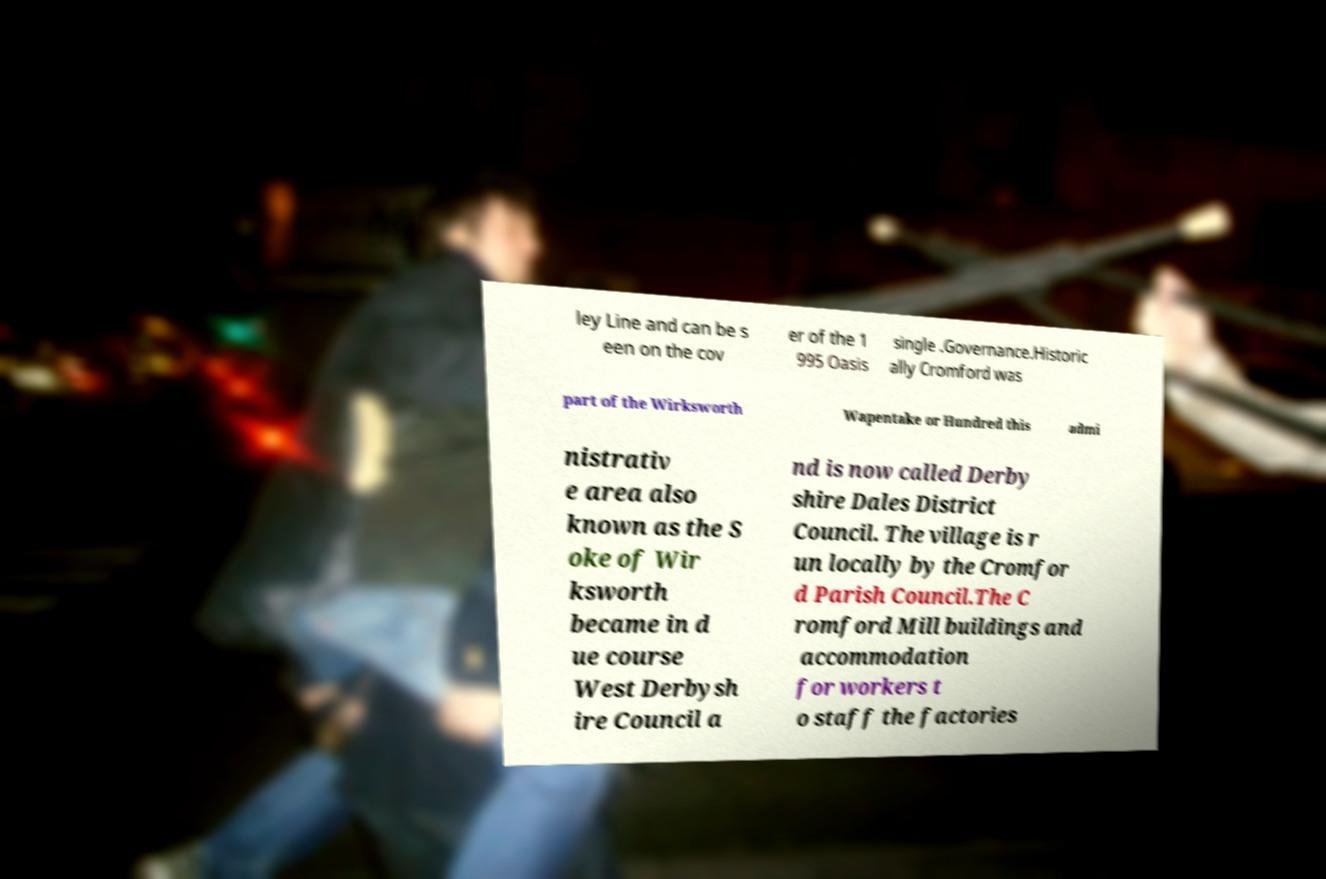Could you assist in decoding the text presented in this image and type it out clearly? ley Line and can be s een on the cov er of the 1 995 Oasis single .Governance.Historic ally Cromford was part of the Wirksworth Wapentake or Hundred this admi nistrativ e area also known as the S oke of Wir ksworth became in d ue course West Derbysh ire Council a nd is now called Derby shire Dales District Council. The village is r un locally by the Cromfor d Parish Council.The C romford Mill buildings and accommodation for workers t o staff the factories 